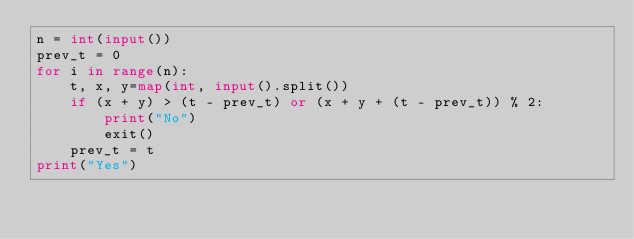<code> <loc_0><loc_0><loc_500><loc_500><_Python_>n = int(input())
prev_t = 0
for i in range(n):
    t, x, y=map(int, input().split())
    if (x + y) > (t - prev_t) or (x + y + (t - prev_t)) % 2:
        print("No")
        exit()
    prev_t = t
print("Yes")</code> 